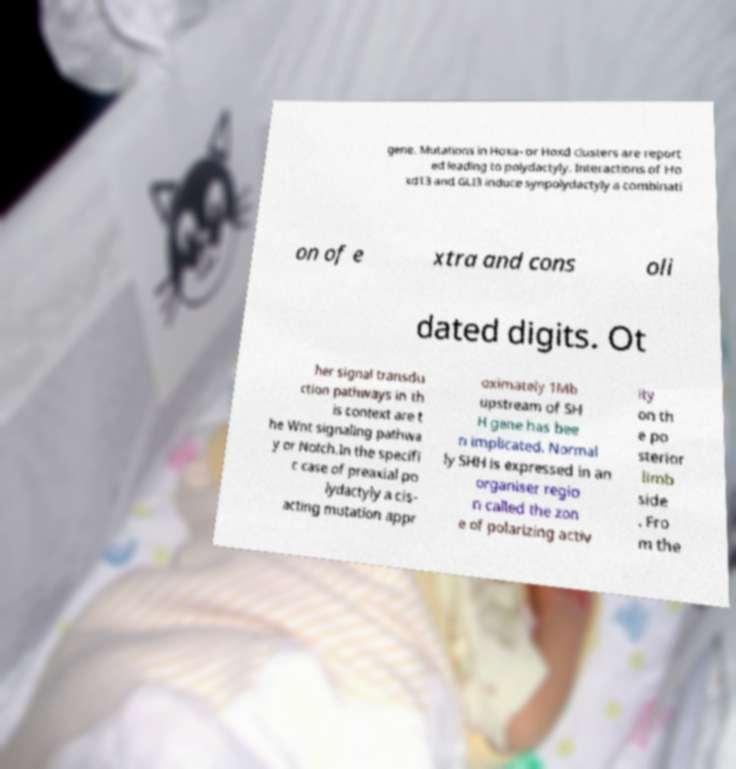For documentation purposes, I need the text within this image transcribed. Could you provide that? gene. Mutations in Hoxa- or Hoxd clusters are report ed leading to polydactyly. Interactions of Ho xd13 and GLI3 induce synpolydactyly a combinati on of e xtra and cons oli dated digits. Ot her signal transdu ction pathways in th is context are t he Wnt signaling pathwa y or Notch.In the specifi c case of preaxial po lydactyly a cis- acting mutation appr oximately 1Mb upstream of SH H gene has bee n implicated. Normal ly SHH is expressed in an organiser regio n called the zon e of polarizing activ ity on th e po sterior limb side . Fro m the 